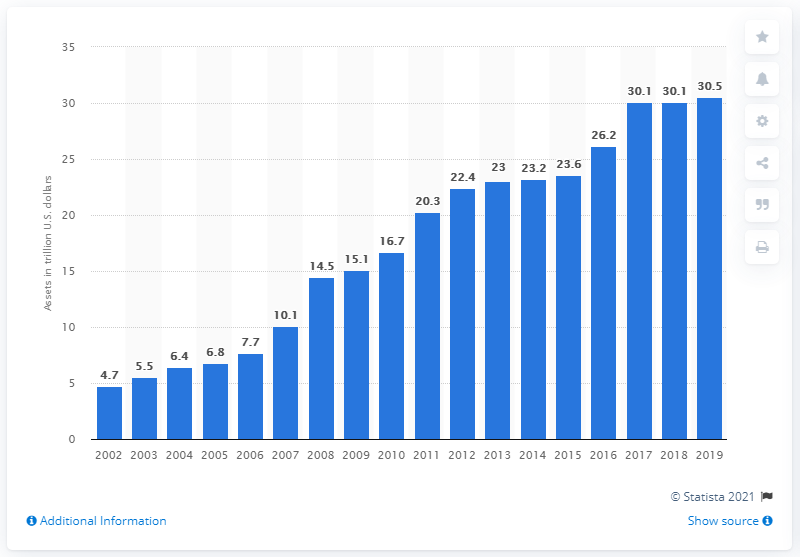Give some essential details in this illustration. The total assets of central banks worldwide increased between the year 2002 and the present. The assets of central banks in 2018 were valued at 30.1 trillion dollars. In 2019, the assets of central banks globally were valued at approximately $30.5 trillion. 